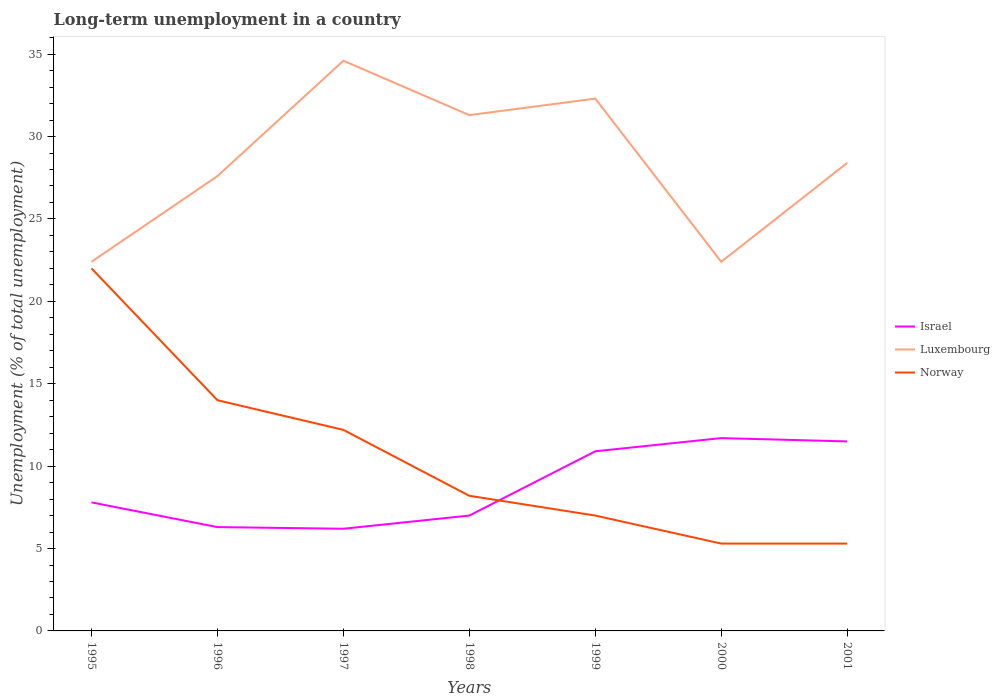How many different coloured lines are there?
Offer a very short reply. 3. Is the number of lines equal to the number of legend labels?
Keep it short and to the point. Yes. Across all years, what is the maximum percentage of long-term unemployed population in Luxembourg?
Your answer should be very brief. 22.4. In which year was the percentage of long-term unemployed population in Luxembourg maximum?
Offer a terse response. 1995. What is the difference between the highest and the second highest percentage of long-term unemployed population in Israel?
Offer a very short reply. 5.5. What is the difference between the highest and the lowest percentage of long-term unemployed population in Luxembourg?
Make the answer very short. 3. Is the percentage of long-term unemployed population in Norway strictly greater than the percentage of long-term unemployed population in Israel over the years?
Offer a very short reply. No. How many lines are there?
Make the answer very short. 3. How many years are there in the graph?
Provide a succinct answer. 7. What is the difference between two consecutive major ticks on the Y-axis?
Your answer should be very brief. 5. Are the values on the major ticks of Y-axis written in scientific E-notation?
Make the answer very short. No. Does the graph contain any zero values?
Provide a succinct answer. No. Does the graph contain grids?
Your response must be concise. No. Where does the legend appear in the graph?
Ensure brevity in your answer.  Center right. How are the legend labels stacked?
Keep it short and to the point. Vertical. What is the title of the graph?
Keep it short and to the point. Long-term unemployment in a country. What is the label or title of the X-axis?
Offer a terse response. Years. What is the label or title of the Y-axis?
Provide a short and direct response. Unemployment (% of total unemployment). What is the Unemployment (% of total unemployment) in Israel in 1995?
Provide a succinct answer. 7.8. What is the Unemployment (% of total unemployment) in Luxembourg in 1995?
Give a very brief answer. 22.4. What is the Unemployment (% of total unemployment) of Norway in 1995?
Ensure brevity in your answer.  22. What is the Unemployment (% of total unemployment) in Israel in 1996?
Offer a very short reply. 6.3. What is the Unemployment (% of total unemployment) in Luxembourg in 1996?
Provide a short and direct response. 27.6. What is the Unemployment (% of total unemployment) of Israel in 1997?
Keep it short and to the point. 6.2. What is the Unemployment (% of total unemployment) in Luxembourg in 1997?
Keep it short and to the point. 34.6. What is the Unemployment (% of total unemployment) of Norway in 1997?
Your answer should be compact. 12.2. What is the Unemployment (% of total unemployment) in Israel in 1998?
Offer a terse response. 7. What is the Unemployment (% of total unemployment) of Luxembourg in 1998?
Keep it short and to the point. 31.3. What is the Unemployment (% of total unemployment) in Norway in 1998?
Offer a very short reply. 8.2. What is the Unemployment (% of total unemployment) in Israel in 1999?
Your answer should be compact. 10.9. What is the Unemployment (% of total unemployment) of Luxembourg in 1999?
Make the answer very short. 32.3. What is the Unemployment (% of total unemployment) in Norway in 1999?
Provide a short and direct response. 7. What is the Unemployment (% of total unemployment) of Israel in 2000?
Offer a terse response. 11.7. What is the Unemployment (% of total unemployment) in Luxembourg in 2000?
Your response must be concise. 22.4. What is the Unemployment (% of total unemployment) of Norway in 2000?
Make the answer very short. 5.3. What is the Unemployment (% of total unemployment) of Israel in 2001?
Give a very brief answer. 11.5. What is the Unemployment (% of total unemployment) of Luxembourg in 2001?
Offer a terse response. 28.4. What is the Unemployment (% of total unemployment) in Norway in 2001?
Ensure brevity in your answer.  5.3. Across all years, what is the maximum Unemployment (% of total unemployment) in Israel?
Your answer should be compact. 11.7. Across all years, what is the maximum Unemployment (% of total unemployment) in Luxembourg?
Provide a succinct answer. 34.6. Across all years, what is the minimum Unemployment (% of total unemployment) of Israel?
Ensure brevity in your answer.  6.2. Across all years, what is the minimum Unemployment (% of total unemployment) in Luxembourg?
Offer a very short reply. 22.4. Across all years, what is the minimum Unemployment (% of total unemployment) in Norway?
Offer a terse response. 5.3. What is the total Unemployment (% of total unemployment) in Israel in the graph?
Make the answer very short. 61.4. What is the total Unemployment (% of total unemployment) in Luxembourg in the graph?
Provide a succinct answer. 199. What is the difference between the Unemployment (% of total unemployment) in Israel in 1995 and that in 1996?
Make the answer very short. 1.5. What is the difference between the Unemployment (% of total unemployment) of Israel in 1995 and that in 1997?
Provide a short and direct response. 1.6. What is the difference between the Unemployment (% of total unemployment) of Israel in 1995 and that in 1999?
Give a very brief answer. -3.1. What is the difference between the Unemployment (% of total unemployment) in Luxembourg in 1995 and that in 1999?
Offer a very short reply. -9.9. What is the difference between the Unemployment (% of total unemployment) in Israel in 1995 and that in 2000?
Your response must be concise. -3.9. What is the difference between the Unemployment (% of total unemployment) in Luxembourg in 1995 and that in 2000?
Your answer should be very brief. 0. What is the difference between the Unemployment (% of total unemployment) of Norway in 1995 and that in 2000?
Keep it short and to the point. 16.7. What is the difference between the Unemployment (% of total unemployment) in Israel in 1995 and that in 2001?
Provide a short and direct response. -3.7. What is the difference between the Unemployment (% of total unemployment) of Israel in 1996 and that in 1997?
Offer a terse response. 0.1. What is the difference between the Unemployment (% of total unemployment) in Israel in 1996 and that in 1998?
Your answer should be compact. -0.7. What is the difference between the Unemployment (% of total unemployment) of Israel in 1996 and that in 1999?
Offer a very short reply. -4.6. What is the difference between the Unemployment (% of total unemployment) of Israel in 1996 and that in 2000?
Provide a short and direct response. -5.4. What is the difference between the Unemployment (% of total unemployment) of Luxembourg in 1996 and that in 2000?
Offer a terse response. 5.2. What is the difference between the Unemployment (% of total unemployment) in Israel in 1996 and that in 2001?
Give a very brief answer. -5.2. What is the difference between the Unemployment (% of total unemployment) of Luxembourg in 1996 and that in 2001?
Your answer should be compact. -0.8. What is the difference between the Unemployment (% of total unemployment) of Norway in 1996 and that in 2001?
Keep it short and to the point. 8.7. What is the difference between the Unemployment (% of total unemployment) in Israel in 1997 and that in 1998?
Your answer should be very brief. -0.8. What is the difference between the Unemployment (% of total unemployment) in Israel in 1997 and that in 2001?
Your answer should be very brief. -5.3. What is the difference between the Unemployment (% of total unemployment) in Luxembourg in 1997 and that in 2001?
Your answer should be very brief. 6.2. What is the difference between the Unemployment (% of total unemployment) in Israel in 1998 and that in 2000?
Offer a very short reply. -4.7. What is the difference between the Unemployment (% of total unemployment) of Luxembourg in 1998 and that in 2000?
Give a very brief answer. 8.9. What is the difference between the Unemployment (% of total unemployment) of Israel in 1998 and that in 2001?
Offer a very short reply. -4.5. What is the difference between the Unemployment (% of total unemployment) of Luxembourg in 1998 and that in 2001?
Ensure brevity in your answer.  2.9. What is the difference between the Unemployment (% of total unemployment) of Norway in 1998 and that in 2001?
Make the answer very short. 2.9. What is the difference between the Unemployment (% of total unemployment) in Israel in 1999 and that in 2000?
Make the answer very short. -0.8. What is the difference between the Unemployment (% of total unemployment) of Israel in 1999 and that in 2001?
Your answer should be compact. -0.6. What is the difference between the Unemployment (% of total unemployment) in Norway in 1999 and that in 2001?
Keep it short and to the point. 1.7. What is the difference between the Unemployment (% of total unemployment) of Luxembourg in 2000 and that in 2001?
Provide a succinct answer. -6. What is the difference between the Unemployment (% of total unemployment) of Israel in 1995 and the Unemployment (% of total unemployment) of Luxembourg in 1996?
Keep it short and to the point. -19.8. What is the difference between the Unemployment (% of total unemployment) in Israel in 1995 and the Unemployment (% of total unemployment) in Norway in 1996?
Provide a short and direct response. -6.2. What is the difference between the Unemployment (% of total unemployment) of Israel in 1995 and the Unemployment (% of total unemployment) of Luxembourg in 1997?
Your answer should be very brief. -26.8. What is the difference between the Unemployment (% of total unemployment) in Israel in 1995 and the Unemployment (% of total unemployment) in Norway in 1997?
Ensure brevity in your answer.  -4.4. What is the difference between the Unemployment (% of total unemployment) of Israel in 1995 and the Unemployment (% of total unemployment) of Luxembourg in 1998?
Make the answer very short. -23.5. What is the difference between the Unemployment (% of total unemployment) of Israel in 1995 and the Unemployment (% of total unemployment) of Luxembourg in 1999?
Make the answer very short. -24.5. What is the difference between the Unemployment (% of total unemployment) in Israel in 1995 and the Unemployment (% of total unemployment) in Norway in 1999?
Provide a succinct answer. 0.8. What is the difference between the Unemployment (% of total unemployment) in Israel in 1995 and the Unemployment (% of total unemployment) in Luxembourg in 2000?
Give a very brief answer. -14.6. What is the difference between the Unemployment (% of total unemployment) in Israel in 1995 and the Unemployment (% of total unemployment) in Norway in 2000?
Your answer should be compact. 2.5. What is the difference between the Unemployment (% of total unemployment) in Luxembourg in 1995 and the Unemployment (% of total unemployment) in Norway in 2000?
Provide a short and direct response. 17.1. What is the difference between the Unemployment (% of total unemployment) of Israel in 1995 and the Unemployment (% of total unemployment) of Luxembourg in 2001?
Your answer should be compact. -20.6. What is the difference between the Unemployment (% of total unemployment) in Israel in 1995 and the Unemployment (% of total unemployment) in Norway in 2001?
Provide a succinct answer. 2.5. What is the difference between the Unemployment (% of total unemployment) of Luxembourg in 1995 and the Unemployment (% of total unemployment) of Norway in 2001?
Your answer should be very brief. 17.1. What is the difference between the Unemployment (% of total unemployment) of Israel in 1996 and the Unemployment (% of total unemployment) of Luxembourg in 1997?
Provide a short and direct response. -28.3. What is the difference between the Unemployment (% of total unemployment) of Israel in 1996 and the Unemployment (% of total unemployment) of Norway in 1997?
Make the answer very short. -5.9. What is the difference between the Unemployment (% of total unemployment) of Luxembourg in 1996 and the Unemployment (% of total unemployment) of Norway in 1998?
Keep it short and to the point. 19.4. What is the difference between the Unemployment (% of total unemployment) of Israel in 1996 and the Unemployment (% of total unemployment) of Luxembourg in 1999?
Your answer should be very brief. -26. What is the difference between the Unemployment (% of total unemployment) in Israel in 1996 and the Unemployment (% of total unemployment) in Norway in 1999?
Give a very brief answer. -0.7. What is the difference between the Unemployment (% of total unemployment) of Luxembourg in 1996 and the Unemployment (% of total unemployment) of Norway in 1999?
Your answer should be compact. 20.6. What is the difference between the Unemployment (% of total unemployment) in Israel in 1996 and the Unemployment (% of total unemployment) in Luxembourg in 2000?
Make the answer very short. -16.1. What is the difference between the Unemployment (% of total unemployment) of Israel in 1996 and the Unemployment (% of total unemployment) of Norway in 2000?
Make the answer very short. 1. What is the difference between the Unemployment (% of total unemployment) in Luxembourg in 1996 and the Unemployment (% of total unemployment) in Norway in 2000?
Give a very brief answer. 22.3. What is the difference between the Unemployment (% of total unemployment) of Israel in 1996 and the Unemployment (% of total unemployment) of Luxembourg in 2001?
Make the answer very short. -22.1. What is the difference between the Unemployment (% of total unemployment) of Israel in 1996 and the Unemployment (% of total unemployment) of Norway in 2001?
Offer a terse response. 1. What is the difference between the Unemployment (% of total unemployment) of Luxembourg in 1996 and the Unemployment (% of total unemployment) of Norway in 2001?
Keep it short and to the point. 22.3. What is the difference between the Unemployment (% of total unemployment) of Israel in 1997 and the Unemployment (% of total unemployment) of Luxembourg in 1998?
Provide a short and direct response. -25.1. What is the difference between the Unemployment (% of total unemployment) of Israel in 1997 and the Unemployment (% of total unemployment) of Norway in 1998?
Your answer should be very brief. -2. What is the difference between the Unemployment (% of total unemployment) in Luxembourg in 1997 and the Unemployment (% of total unemployment) in Norway in 1998?
Give a very brief answer. 26.4. What is the difference between the Unemployment (% of total unemployment) in Israel in 1997 and the Unemployment (% of total unemployment) in Luxembourg in 1999?
Make the answer very short. -26.1. What is the difference between the Unemployment (% of total unemployment) in Israel in 1997 and the Unemployment (% of total unemployment) in Norway in 1999?
Keep it short and to the point. -0.8. What is the difference between the Unemployment (% of total unemployment) in Luxembourg in 1997 and the Unemployment (% of total unemployment) in Norway in 1999?
Offer a very short reply. 27.6. What is the difference between the Unemployment (% of total unemployment) of Israel in 1997 and the Unemployment (% of total unemployment) of Luxembourg in 2000?
Offer a very short reply. -16.2. What is the difference between the Unemployment (% of total unemployment) in Israel in 1997 and the Unemployment (% of total unemployment) in Norway in 2000?
Keep it short and to the point. 0.9. What is the difference between the Unemployment (% of total unemployment) in Luxembourg in 1997 and the Unemployment (% of total unemployment) in Norway in 2000?
Keep it short and to the point. 29.3. What is the difference between the Unemployment (% of total unemployment) in Israel in 1997 and the Unemployment (% of total unemployment) in Luxembourg in 2001?
Your response must be concise. -22.2. What is the difference between the Unemployment (% of total unemployment) of Luxembourg in 1997 and the Unemployment (% of total unemployment) of Norway in 2001?
Offer a terse response. 29.3. What is the difference between the Unemployment (% of total unemployment) of Israel in 1998 and the Unemployment (% of total unemployment) of Luxembourg in 1999?
Your answer should be very brief. -25.3. What is the difference between the Unemployment (% of total unemployment) in Israel in 1998 and the Unemployment (% of total unemployment) in Norway in 1999?
Keep it short and to the point. 0. What is the difference between the Unemployment (% of total unemployment) of Luxembourg in 1998 and the Unemployment (% of total unemployment) of Norway in 1999?
Give a very brief answer. 24.3. What is the difference between the Unemployment (% of total unemployment) of Israel in 1998 and the Unemployment (% of total unemployment) of Luxembourg in 2000?
Keep it short and to the point. -15.4. What is the difference between the Unemployment (% of total unemployment) in Luxembourg in 1998 and the Unemployment (% of total unemployment) in Norway in 2000?
Your response must be concise. 26. What is the difference between the Unemployment (% of total unemployment) of Israel in 1998 and the Unemployment (% of total unemployment) of Luxembourg in 2001?
Give a very brief answer. -21.4. What is the difference between the Unemployment (% of total unemployment) in Luxembourg in 1998 and the Unemployment (% of total unemployment) in Norway in 2001?
Provide a short and direct response. 26. What is the difference between the Unemployment (% of total unemployment) of Israel in 1999 and the Unemployment (% of total unemployment) of Norway in 2000?
Make the answer very short. 5.6. What is the difference between the Unemployment (% of total unemployment) in Luxembourg in 1999 and the Unemployment (% of total unemployment) in Norway in 2000?
Give a very brief answer. 27. What is the difference between the Unemployment (% of total unemployment) of Israel in 1999 and the Unemployment (% of total unemployment) of Luxembourg in 2001?
Make the answer very short. -17.5. What is the difference between the Unemployment (% of total unemployment) of Luxembourg in 1999 and the Unemployment (% of total unemployment) of Norway in 2001?
Provide a short and direct response. 27. What is the difference between the Unemployment (% of total unemployment) in Israel in 2000 and the Unemployment (% of total unemployment) in Luxembourg in 2001?
Give a very brief answer. -16.7. What is the average Unemployment (% of total unemployment) of Israel per year?
Ensure brevity in your answer.  8.77. What is the average Unemployment (% of total unemployment) of Luxembourg per year?
Make the answer very short. 28.43. What is the average Unemployment (% of total unemployment) of Norway per year?
Keep it short and to the point. 10.57. In the year 1995, what is the difference between the Unemployment (% of total unemployment) in Israel and Unemployment (% of total unemployment) in Luxembourg?
Give a very brief answer. -14.6. In the year 1995, what is the difference between the Unemployment (% of total unemployment) in Luxembourg and Unemployment (% of total unemployment) in Norway?
Provide a short and direct response. 0.4. In the year 1996, what is the difference between the Unemployment (% of total unemployment) in Israel and Unemployment (% of total unemployment) in Luxembourg?
Keep it short and to the point. -21.3. In the year 1996, what is the difference between the Unemployment (% of total unemployment) of Israel and Unemployment (% of total unemployment) of Norway?
Provide a short and direct response. -7.7. In the year 1997, what is the difference between the Unemployment (% of total unemployment) in Israel and Unemployment (% of total unemployment) in Luxembourg?
Your answer should be compact. -28.4. In the year 1997, what is the difference between the Unemployment (% of total unemployment) in Luxembourg and Unemployment (% of total unemployment) in Norway?
Make the answer very short. 22.4. In the year 1998, what is the difference between the Unemployment (% of total unemployment) in Israel and Unemployment (% of total unemployment) in Luxembourg?
Your answer should be compact. -24.3. In the year 1998, what is the difference between the Unemployment (% of total unemployment) in Israel and Unemployment (% of total unemployment) in Norway?
Offer a terse response. -1.2. In the year 1998, what is the difference between the Unemployment (% of total unemployment) of Luxembourg and Unemployment (% of total unemployment) of Norway?
Make the answer very short. 23.1. In the year 1999, what is the difference between the Unemployment (% of total unemployment) in Israel and Unemployment (% of total unemployment) in Luxembourg?
Make the answer very short. -21.4. In the year 1999, what is the difference between the Unemployment (% of total unemployment) in Israel and Unemployment (% of total unemployment) in Norway?
Provide a succinct answer. 3.9. In the year 1999, what is the difference between the Unemployment (% of total unemployment) in Luxembourg and Unemployment (% of total unemployment) in Norway?
Give a very brief answer. 25.3. In the year 2001, what is the difference between the Unemployment (% of total unemployment) in Israel and Unemployment (% of total unemployment) in Luxembourg?
Ensure brevity in your answer.  -16.9. In the year 2001, what is the difference between the Unemployment (% of total unemployment) of Luxembourg and Unemployment (% of total unemployment) of Norway?
Give a very brief answer. 23.1. What is the ratio of the Unemployment (% of total unemployment) of Israel in 1995 to that in 1996?
Your answer should be compact. 1.24. What is the ratio of the Unemployment (% of total unemployment) of Luxembourg in 1995 to that in 1996?
Provide a succinct answer. 0.81. What is the ratio of the Unemployment (% of total unemployment) in Norway in 1995 to that in 1996?
Make the answer very short. 1.57. What is the ratio of the Unemployment (% of total unemployment) in Israel in 1995 to that in 1997?
Provide a succinct answer. 1.26. What is the ratio of the Unemployment (% of total unemployment) of Luxembourg in 1995 to that in 1997?
Provide a short and direct response. 0.65. What is the ratio of the Unemployment (% of total unemployment) of Norway in 1995 to that in 1997?
Offer a very short reply. 1.8. What is the ratio of the Unemployment (% of total unemployment) of Israel in 1995 to that in 1998?
Your answer should be very brief. 1.11. What is the ratio of the Unemployment (% of total unemployment) of Luxembourg in 1995 to that in 1998?
Your response must be concise. 0.72. What is the ratio of the Unemployment (% of total unemployment) in Norway in 1995 to that in 1998?
Give a very brief answer. 2.68. What is the ratio of the Unemployment (% of total unemployment) of Israel in 1995 to that in 1999?
Offer a very short reply. 0.72. What is the ratio of the Unemployment (% of total unemployment) of Luxembourg in 1995 to that in 1999?
Provide a succinct answer. 0.69. What is the ratio of the Unemployment (% of total unemployment) of Norway in 1995 to that in 1999?
Provide a succinct answer. 3.14. What is the ratio of the Unemployment (% of total unemployment) of Israel in 1995 to that in 2000?
Provide a succinct answer. 0.67. What is the ratio of the Unemployment (% of total unemployment) of Norway in 1995 to that in 2000?
Make the answer very short. 4.15. What is the ratio of the Unemployment (% of total unemployment) in Israel in 1995 to that in 2001?
Your answer should be compact. 0.68. What is the ratio of the Unemployment (% of total unemployment) of Luxembourg in 1995 to that in 2001?
Provide a succinct answer. 0.79. What is the ratio of the Unemployment (% of total unemployment) of Norway in 1995 to that in 2001?
Offer a very short reply. 4.15. What is the ratio of the Unemployment (% of total unemployment) in Israel in 1996 to that in 1997?
Your answer should be compact. 1.02. What is the ratio of the Unemployment (% of total unemployment) of Luxembourg in 1996 to that in 1997?
Give a very brief answer. 0.8. What is the ratio of the Unemployment (% of total unemployment) in Norway in 1996 to that in 1997?
Your answer should be compact. 1.15. What is the ratio of the Unemployment (% of total unemployment) in Israel in 1996 to that in 1998?
Provide a short and direct response. 0.9. What is the ratio of the Unemployment (% of total unemployment) of Luxembourg in 1996 to that in 1998?
Your answer should be compact. 0.88. What is the ratio of the Unemployment (% of total unemployment) of Norway in 1996 to that in 1998?
Ensure brevity in your answer.  1.71. What is the ratio of the Unemployment (% of total unemployment) of Israel in 1996 to that in 1999?
Your answer should be compact. 0.58. What is the ratio of the Unemployment (% of total unemployment) in Luxembourg in 1996 to that in 1999?
Give a very brief answer. 0.85. What is the ratio of the Unemployment (% of total unemployment) of Israel in 1996 to that in 2000?
Keep it short and to the point. 0.54. What is the ratio of the Unemployment (% of total unemployment) of Luxembourg in 1996 to that in 2000?
Your response must be concise. 1.23. What is the ratio of the Unemployment (% of total unemployment) in Norway in 1996 to that in 2000?
Ensure brevity in your answer.  2.64. What is the ratio of the Unemployment (% of total unemployment) in Israel in 1996 to that in 2001?
Ensure brevity in your answer.  0.55. What is the ratio of the Unemployment (% of total unemployment) of Luxembourg in 1996 to that in 2001?
Offer a terse response. 0.97. What is the ratio of the Unemployment (% of total unemployment) of Norway in 1996 to that in 2001?
Your answer should be compact. 2.64. What is the ratio of the Unemployment (% of total unemployment) in Israel in 1997 to that in 1998?
Keep it short and to the point. 0.89. What is the ratio of the Unemployment (% of total unemployment) of Luxembourg in 1997 to that in 1998?
Provide a short and direct response. 1.11. What is the ratio of the Unemployment (% of total unemployment) in Norway in 1997 to that in 1998?
Your response must be concise. 1.49. What is the ratio of the Unemployment (% of total unemployment) of Israel in 1997 to that in 1999?
Your answer should be very brief. 0.57. What is the ratio of the Unemployment (% of total unemployment) in Luxembourg in 1997 to that in 1999?
Make the answer very short. 1.07. What is the ratio of the Unemployment (% of total unemployment) in Norway in 1997 to that in 1999?
Make the answer very short. 1.74. What is the ratio of the Unemployment (% of total unemployment) in Israel in 1997 to that in 2000?
Keep it short and to the point. 0.53. What is the ratio of the Unemployment (% of total unemployment) of Luxembourg in 1997 to that in 2000?
Your answer should be very brief. 1.54. What is the ratio of the Unemployment (% of total unemployment) in Norway in 1997 to that in 2000?
Offer a terse response. 2.3. What is the ratio of the Unemployment (% of total unemployment) of Israel in 1997 to that in 2001?
Your answer should be compact. 0.54. What is the ratio of the Unemployment (% of total unemployment) of Luxembourg in 1997 to that in 2001?
Your answer should be very brief. 1.22. What is the ratio of the Unemployment (% of total unemployment) in Norway in 1997 to that in 2001?
Your answer should be very brief. 2.3. What is the ratio of the Unemployment (% of total unemployment) in Israel in 1998 to that in 1999?
Make the answer very short. 0.64. What is the ratio of the Unemployment (% of total unemployment) in Norway in 1998 to that in 1999?
Your answer should be compact. 1.17. What is the ratio of the Unemployment (% of total unemployment) in Israel in 1998 to that in 2000?
Ensure brevity in your answer.  0.6. What is the ratio of the Unemployment (% of total unemployment) in Luxembourg in 1998 to that in 2000?
Make the answer very short. 1.4. What is the ratio of the Unemployment (% of total unemployment) in Norway in 1998 to that in 2000?
Provide a succinct answer. 1.55. What is the ratio of the Unemployment (% of total unemployment) in Israel in 1998 to that in 2001?
Keep it short and to the point. 0.61. What is the ratio of the Unemployment (% of total unemployment) in Luxembourg in 1998 to that in 2001?
Offer a very short reply. 1.1. What is the ratio of the Unemployment (% of total unemployment) of Norway in 1998 to that in 2001?
Your answer should be very brief. 1.55. What is the ratio of the Unemployment (% of total unemployment) of Israel in 1999 to that in 2000?
Offer a very short reply. 0.93. What is the ratio of the Unemployment (% of total unemployment) of Luxembourg in 1999 to that in 2000?
Your answer should be very brief. 1.44. What is the ratio of the Unemployment (% of total unemployment) of Norway in 1999 to that in 2000?
Offer a very short reply. 1.32. What is the ratio of the Unemployment (% of total unemployment) of Israel in 1999 to that in 2001?
Offer a very short reply. 0.95. What is the ratio of the Unemployment (% of total unemployment) in Luxembourg in 1999 to that in 2001?
Your answer should be very brief. 1.14. What is the ratio of the Unemployment (% of total unemployment) in Norway in 1999 to that in 2001?
Keep it short and to the point. 1.32. What is the ratio of the Unemployment (% of total unemployment) of Israel in 2000 to that in 2001?
Give a very brief answer. 1.02. What is the ratio of the Unemployment (% of total unemployment) of Luxembourg in 2000 to that in 2001?
Provide a short and direct response. 0.79. What is the difference between the highest and the second highest Unemployment (% of total unemployment) of Israel?
Offer a very short reply. 0.2. What is the difference between the highest and the lowest Unemployment (% of total unemployment) in Israel?
Give a very brief answer. 5.5. What is the difference between the highest and the lowest Unemployment (% of total unemployment) of Luxembourg?
Your response must be concise. 12.2. What is the difference between the highest and the lowest Unemployment (% of total unemployment) of Norway?
Keep it short and to the point. 16.7. 